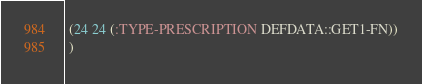Convert code to text. <code><loc_0><loc_0><loc_500><loc_500><_Lisp_> (24 24 (:TYPE-PRESCRIPTION DEFDATA::GET1-FN))
 )
</code> 